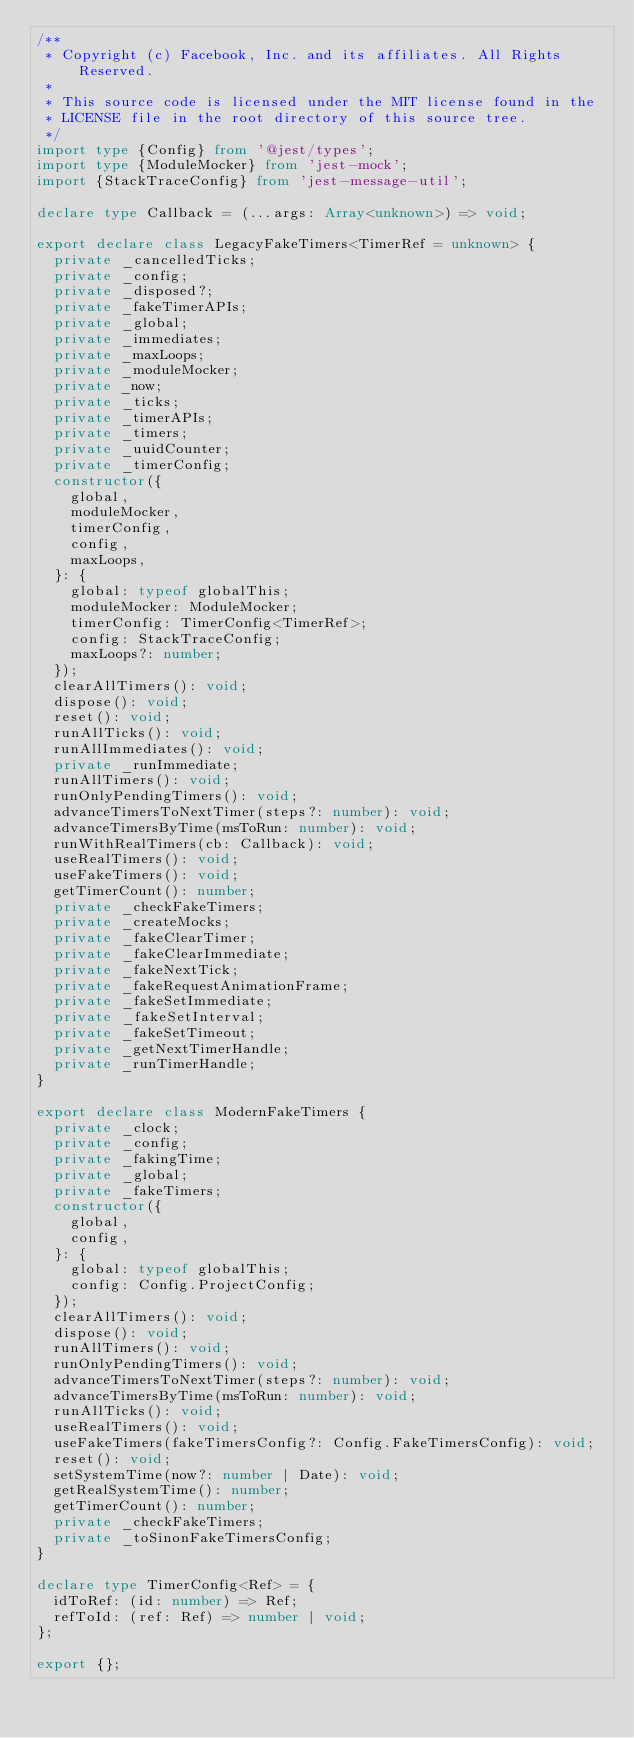<code> <loc_0><loc_0><loc_500><loc_500><_TypeScript_>/**
 * Copyright (c) Facebook, Inc. and its affiliates. All Rights Reserved.
 *
 * This source code is licensed under the MIT license found in the
 * LICENSE file in the root directory of this source tree.
 */
import type {Config} from '@jest/types';
import type {ModuleMocker} from 'jest-mock';
import {StackTraceConfig} from 'jest-message-util';

declare type Callback = (...args: Array<unknown>) => void;

export declare class LegacyFakeTimers<TimerRef = unknown> {
  private _cancelledTicks;
  private _config;
  private _disposed?;
  private _fakeTimerAPIs;
  private _global;
  private _immediates;
  private _maxLoops;
  private _moduleMocker;
  private _now;
  private _ticks;
  private _timerAPIs;
  private _timers;
  private _uuidCounter;
  private _timerConfig;
  constructor({
    global,
    moduleMocker,
    timerConfig,
    config,
    maxLoops,
  }: {
    global: typeof globalThis;
    moduleMocker: ModuleMocker;
    timerConfig: TimerConfig<TimerRef>;
    config: StackTraceConfig;
    maxLoops?: number;
  });
  clearAllTimers(): void;
  dispose(): void;
  reset(): void;
  runAllTicks(): void;
  runAllImmediates(): void;
  private _runImmediate;
  runAllTimers(): void;
  runOnlyPendingTimers(): void;
  advanceTimersToNextTimer(steps?: number): void;
  advanceTimersByTime(msToRun: number): void;
  runWithRealTimers(cb: Callback): void;
  useRealTimers(): void;
  useFakeTimers(): void;
  getTimerCount(): number;
  private _checkFakeTimers;
  private _createMocks;
  private _fakeClearTimer;
  private _fakeClearImmediate;
  private _fakeNextTick;
  private _fakeRequestAnimationFrame;
  private _fakeSetImmediate;
  private _fakeSetInterval;
  private _fakeSetTimeout;
  private _getNextTimerHandle;
  private _runTimerHandle;
}

export declare class ModernFakeTimers {
  private _clock;
  private _config;
  private _fakingTime;
  private _global;
  private _fakeTimers;
  constructor({
    global,
    config,
  }: {
    global: typeof globalThis;
    config: Config.ProjectConfig;
  });
  clearAllTimers(): void;
  dispose(): void;
  runAllTimers(): void;
  runOnlyPendingTimers(): void;
  advanceTimersToNextTimer(steps?: number): void;
  advanceTimersByTime(msToRun: number): void;
  runAllTicks(): void;
  useRealTimers(): void;
  useFakeTimers(fakeTimersConfig?: Config.FakeTimersConfig): void;
  reset(): void;
  setSystemTime(now?: number | Date): void;
  getRealSystemTime(): number;
  getTimerCount(): number;
  private _checkFakeTimers;
  private _toSinonFakeTimersConfig;
}

declare type TimerConfig<Ref> = {
  idToRef: (id: number) => Ref;
  refToId: (ref: Ref) => number | void;
};

export {};
</code> 